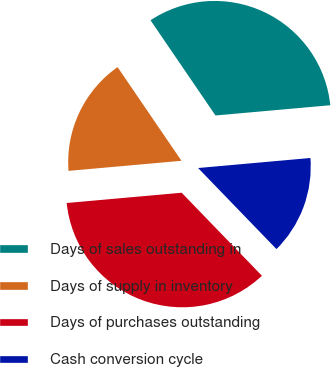Convert chart to OTSL. <chart><loc_0><loc_0><loc_500><loc_500><pie_chart><fcel>Days of sales outstanding in<fcel>Days of supply in inventory<fcel>Days of purchases outstanding<fcel>Cash conversion cycle<nl><fcel>33.11%<fcel>16.89%<fcel>35.81%<fcel>14.19%<nl></chart> 